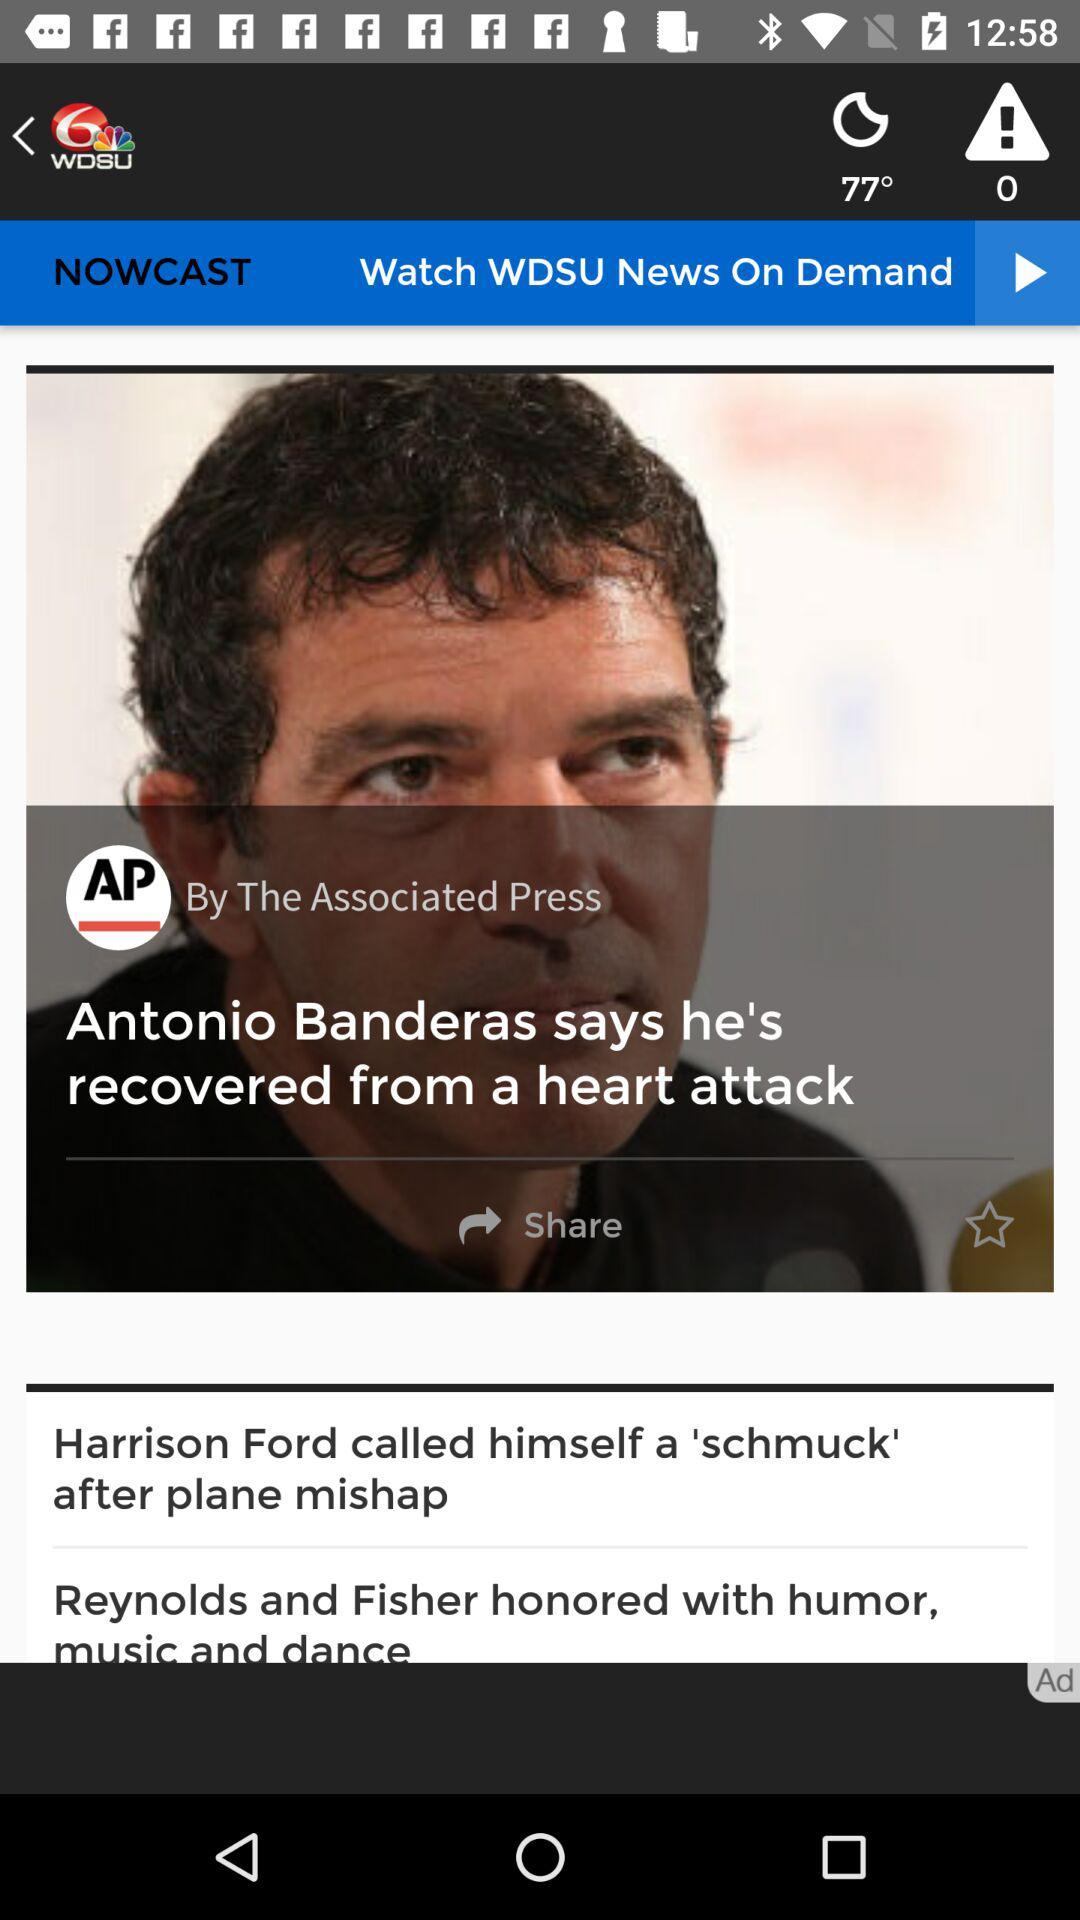What is the name of the application? The name of the application is "WDSU". 